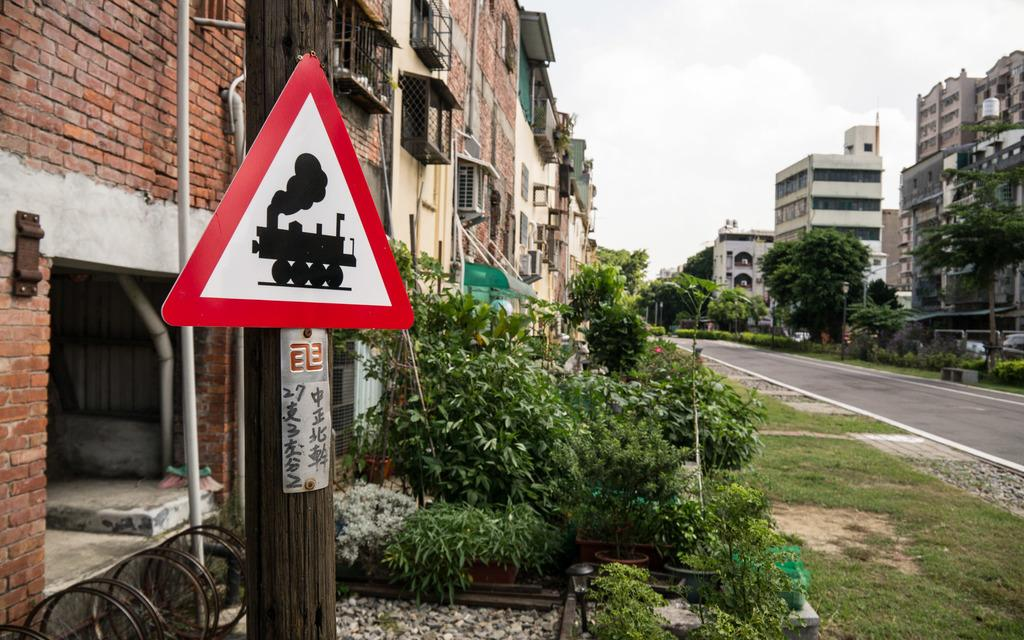<image>
Describe the image concisely. A pole with a triangle on it has Japanese writing under it. 